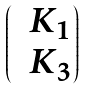Convert formula to latex. <formula><loc_0><loc_0><loc_500><loc_500>\begin{pmatrix} & K _ { 1 } \\ & K _ { 3 } \end{pmatrix}</formula> 